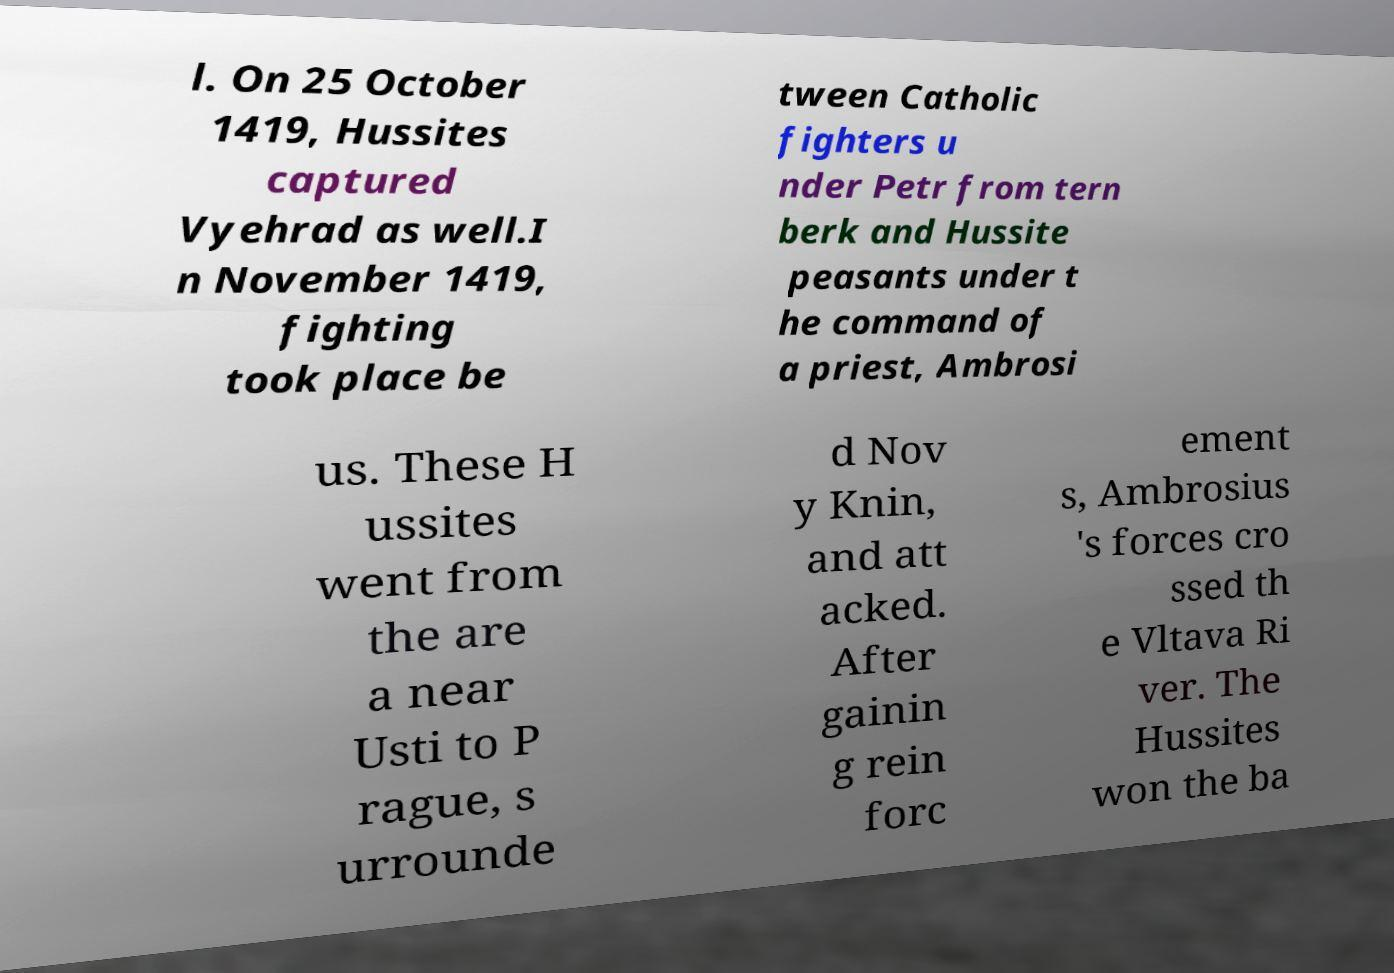For documentation purposes, I need the text within this image transcribed. Could you provide that? l. On 25 October 1419, Hussites captured Vyehrad as well.I n November 1419, fighting took place be tween Catholic fighters u nder Petr from tern berk and Hussite peasants under t he command of a priest, Ambrosi us. These H ussites went from the are a near Usti to P rague, s urrounde d Nov y Knin, and att acked. After gainin g rein forc ement s, Ambrosius 's forces cro ssed th e Vltava Ri ver. The Hussites won the ba 